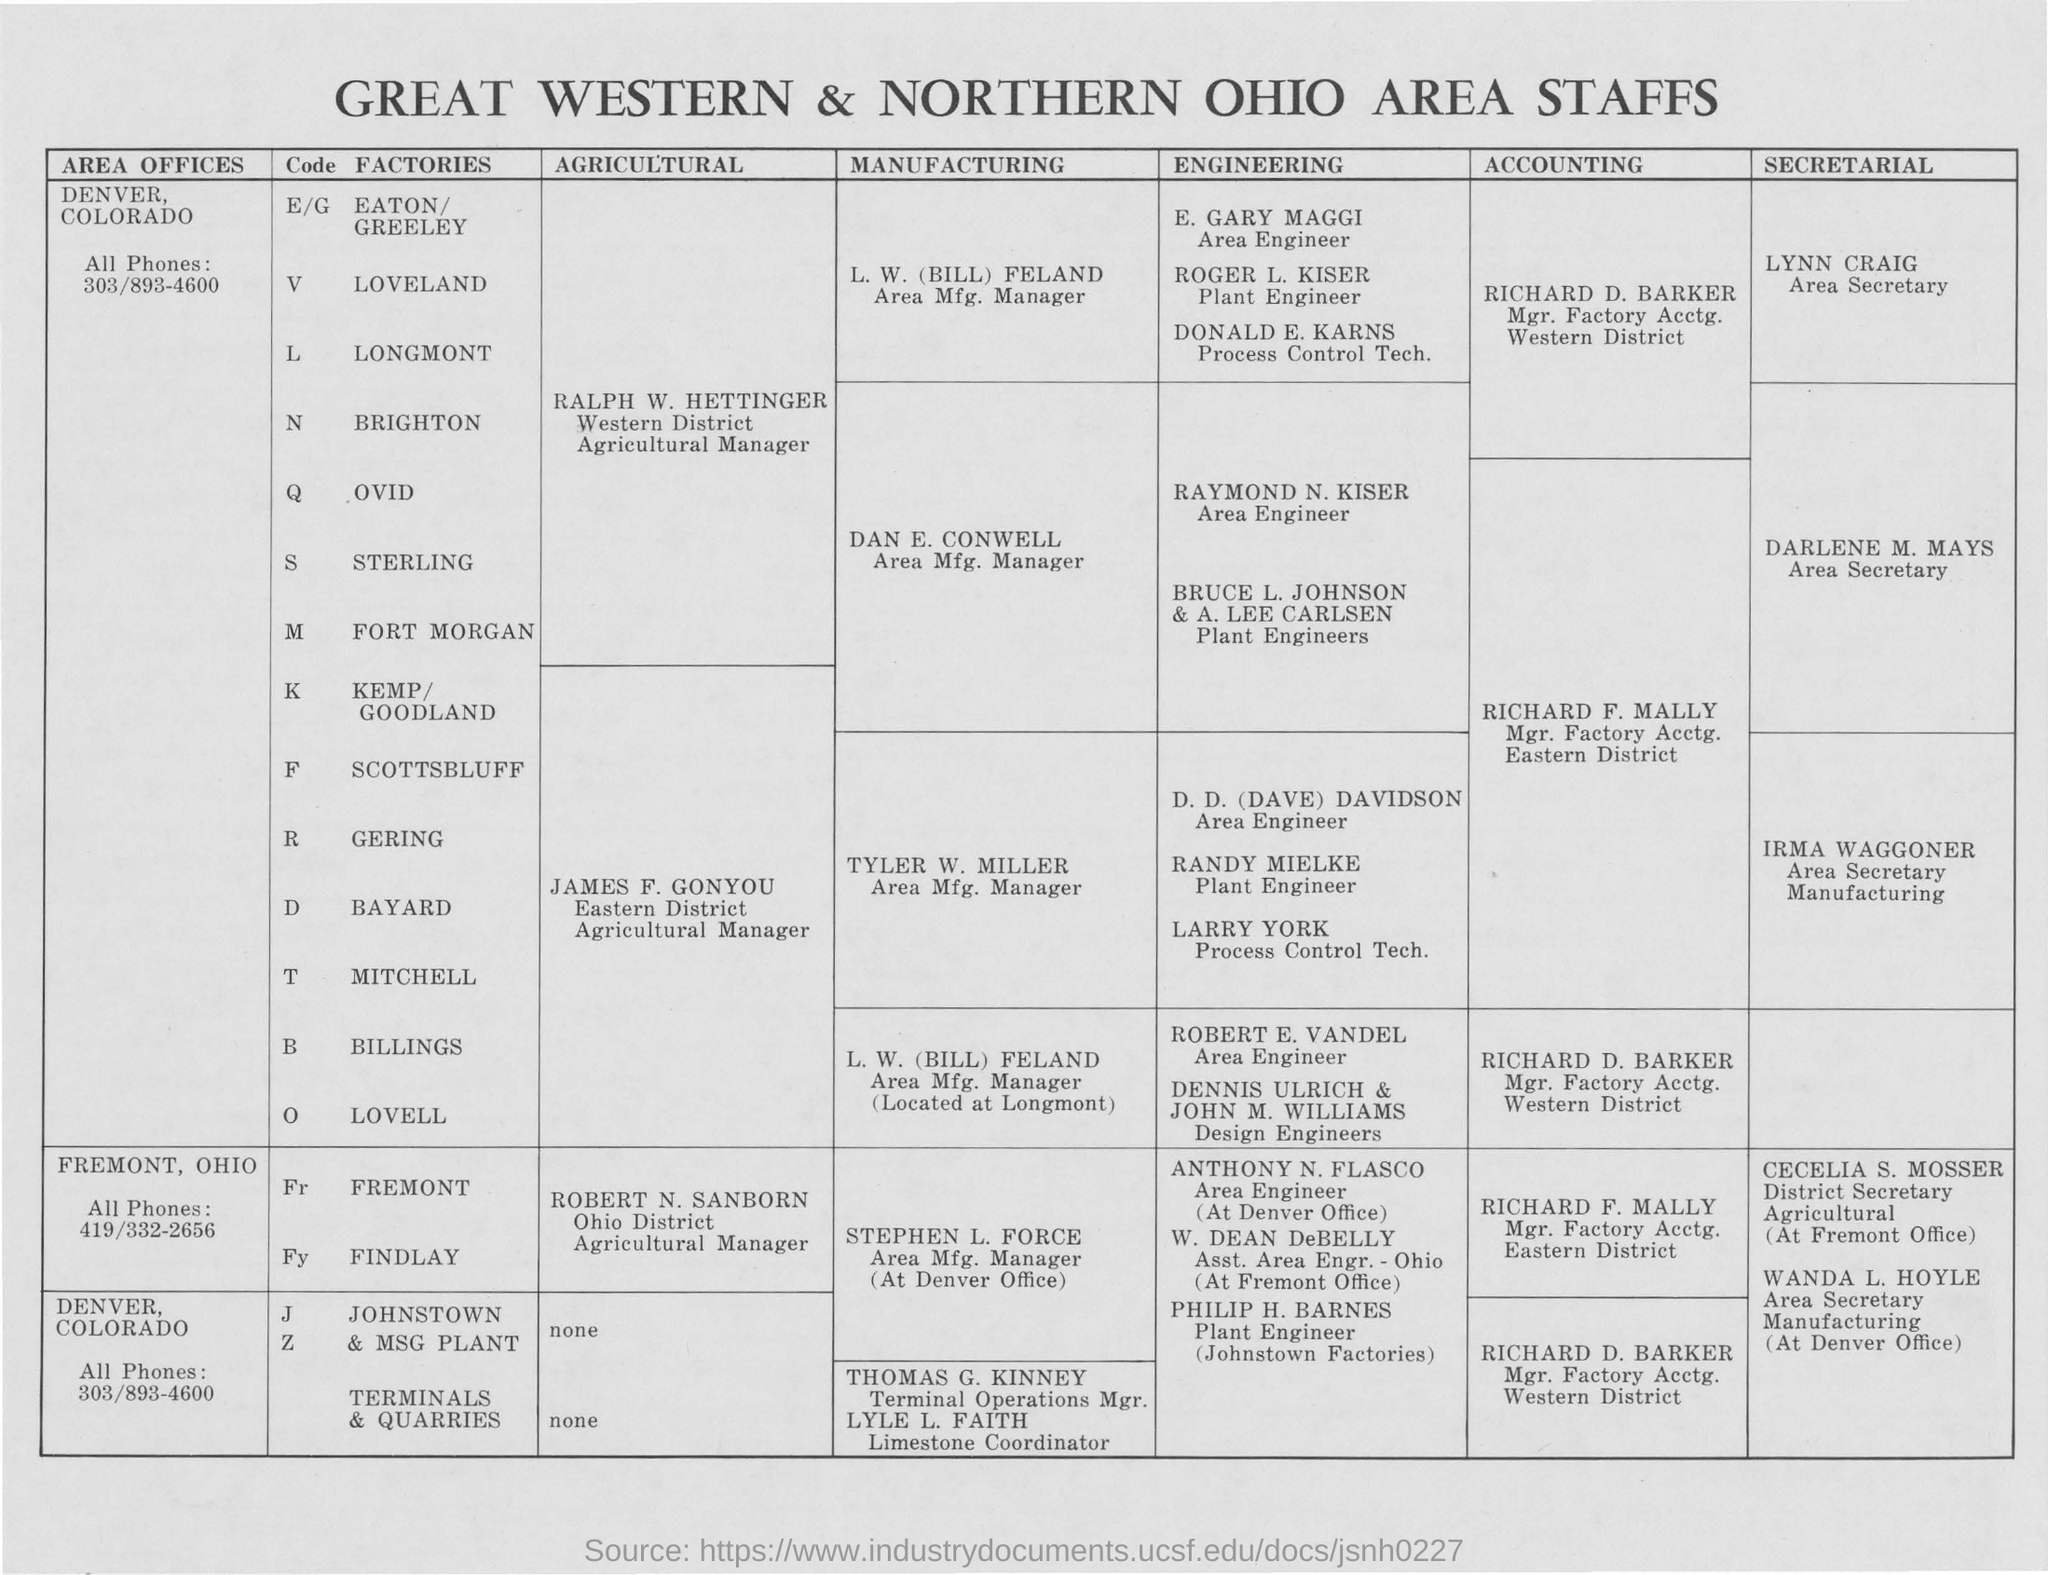Which company area staff it is in the document?
Make the answer very short. GREAT WESTERN & NORTHERN OHIO AREA STAFFS. What is the contact number from the area offices of denver colorado for sterling factory?
Offer a terse response. 303/893-4600. Who is designated as the area mfg. manager for loveland  factory?
Offer a terse response. L. W. (BILL) FELAND. Who is designated as the area engineer for the ovid company ?
Keep it short and to the point. Raymond N. kiser. Who is designated as the Mgr.factory Acctg. for eastern district of gering factory?
Make the answer very short. RICHARD F. MALLY. Who is designated as area secertary for the for the factory of fort morgan?
Offer a terse response. DARLENE M. MAYS. Who is designated as agriculture manager for the findlay factory of Fremont Ohio district?
Your answer should be compact. ROBERT N. SANBORN. Who is designated as the asst. area engineer of ohio at the fremont office ?
Offer a very short reply. W. DEAN DeBELLY. Who is designated as the district secretary agriculture at fremont office ?
Your answer should be very brief. CECELIA S. MOSSER. 